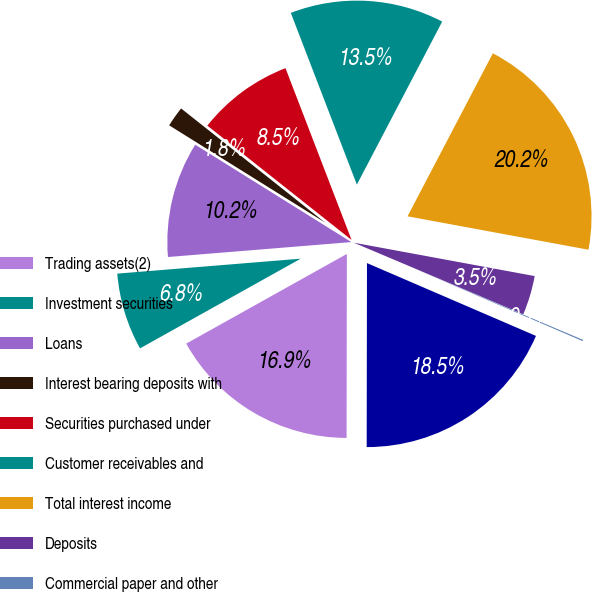Convert chart to OTSL. <chart><loc_0><loc_0><loc_500><loc_500><pie_chart><fcel>Trading assets(2)<fcel>Investment securities<fcel>Loans<fcel>Interest bearing deposits with<fcel>Securities purchased under<fcel>Customer receivables and<fcel>Total interest income<fcel>Deposits<fcel>Commercial paper and other<fcel>Long-term borrowings<nl><fcel>16.87%<fcel>6.81%<fcel>10.17%<fcel>1.79%<fcel>8.49%<fcel>13.52%<fcel>20.23%<fcel>3.46%<fcel>0.11%<fcel>18.55%<nl></chart> 